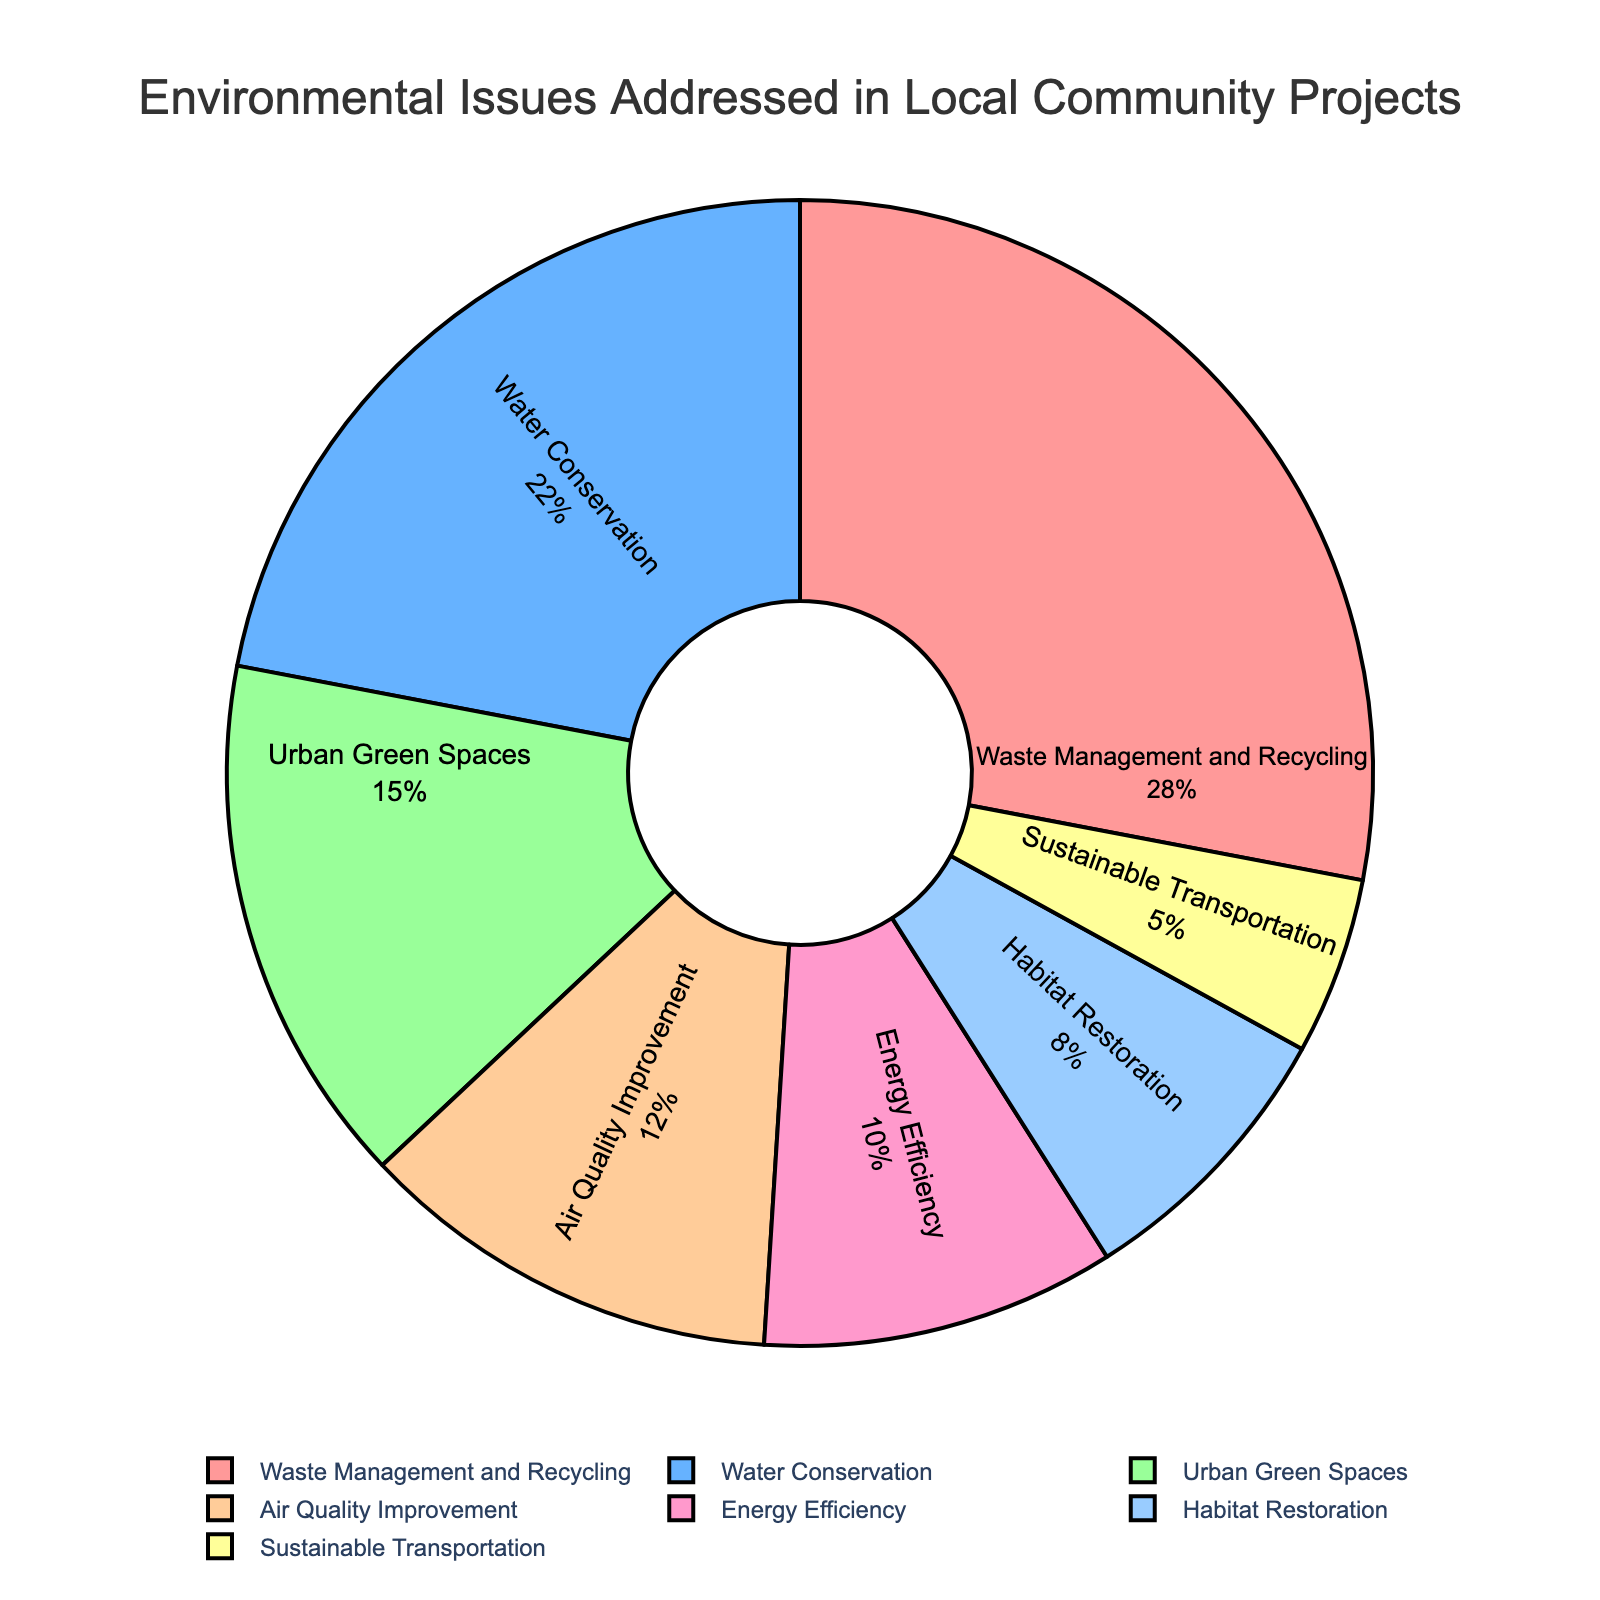What percentage of community projects address Air Quality Improvement? The pie chart lists Air Quality Improvement as 12% in the legend.
Answer: 12% Which environmental issue is the most frequently addressed in local community projects? The largest segment of the pie chart and the highest percentage in the text is Waste Management and Recycling at 28%.
Answer: Waste Management and Recycling How much more focus do Waste Management and Recycling projects get compared to Habitat Restoration projects? Waste Management and Recycling is 28%, and Habitat Restoration is 8%. The difference is 28% - 8% = 20%.
Answer: 20% What is the combined percentage for Urban Green Spaces and Sustainable Transportation projects? Urban Green Spaces is 15% and Sustainable Transportation is 5%. The combined percentage is 15% + 5% = 20%.
Answer: 20% Is the percentage of Water Conservation projects higher than Energy Efficiency projects? Water Conservation is 22%, and Energy Efficiency is 10%. Since 22% is greater than 10%, Water Conservation projects have a higher percentage.
Answer: Yes How does the percentage of projects focused on Urban Green Spaces compare to those focused on Air Quality Improvement? Urban Green Spaces is 15% and Air Quality Improvement is 12%. Comparing these values: 15% > 12%.
Answer: Urban Green Spaces has a higher percentage What is the total percentage of projects that focus on either Waste Management and Recycling or Water Conservation? Waste Management and Recycling is 28% and Water Conservation is 22%. The total is 28% + 22% = 50%.
Answer: 50% Which environmental issue has the smallest share in the community projects? The smallest segment in the pie chart corresponds to Sustainable Transportation with 5%.
Answer: Sustainable Transportation What is the ratio of projects addressing Waste Management and Recycling to those addressing Energy Efficiency? Waste Management and Recycling is 28% and Energy Efficiency is 10%. The ratio is 28:10, which simplifies to 14:5.
Answer: 14:5 What is the average percentage for all types of environmental issues? Sum the percentages: 28 + 22 + 15 + 12 + 10 + 8 + 5 = 100. Divide by the number of categories: 100 / 7 ≈ 14.29%.
Answer: ≈14.29% 